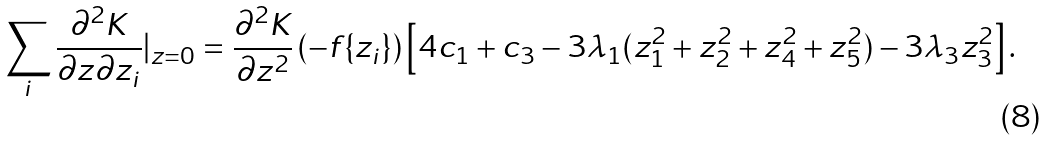<formula> <loc_0><loc_0><loc_500><loc_500>\sum _ { i } \frac { \partial ^ { 2 } K } { \partial z \partial z _ { i } } | _ { z = 0 } = \frac { \partial ^ { 2 } K } { \partial z ^ { 2 } } \left ( - f \{ z _ { i } \} \right ) \left [ 4 c _ { 1 } + c _ { 3 } - 3 \lambda _ { 1 } ( z _ { 1 } ^ { 2 } + z _ { 2 } ^ { 2 } + z _ { 4 } ^ { 2 } + z _ { 5 } ^ { 2 } ) - 3 \lambda _ { 3 } z _ { 3 } ^ { 2 } \right ] .</formula> 